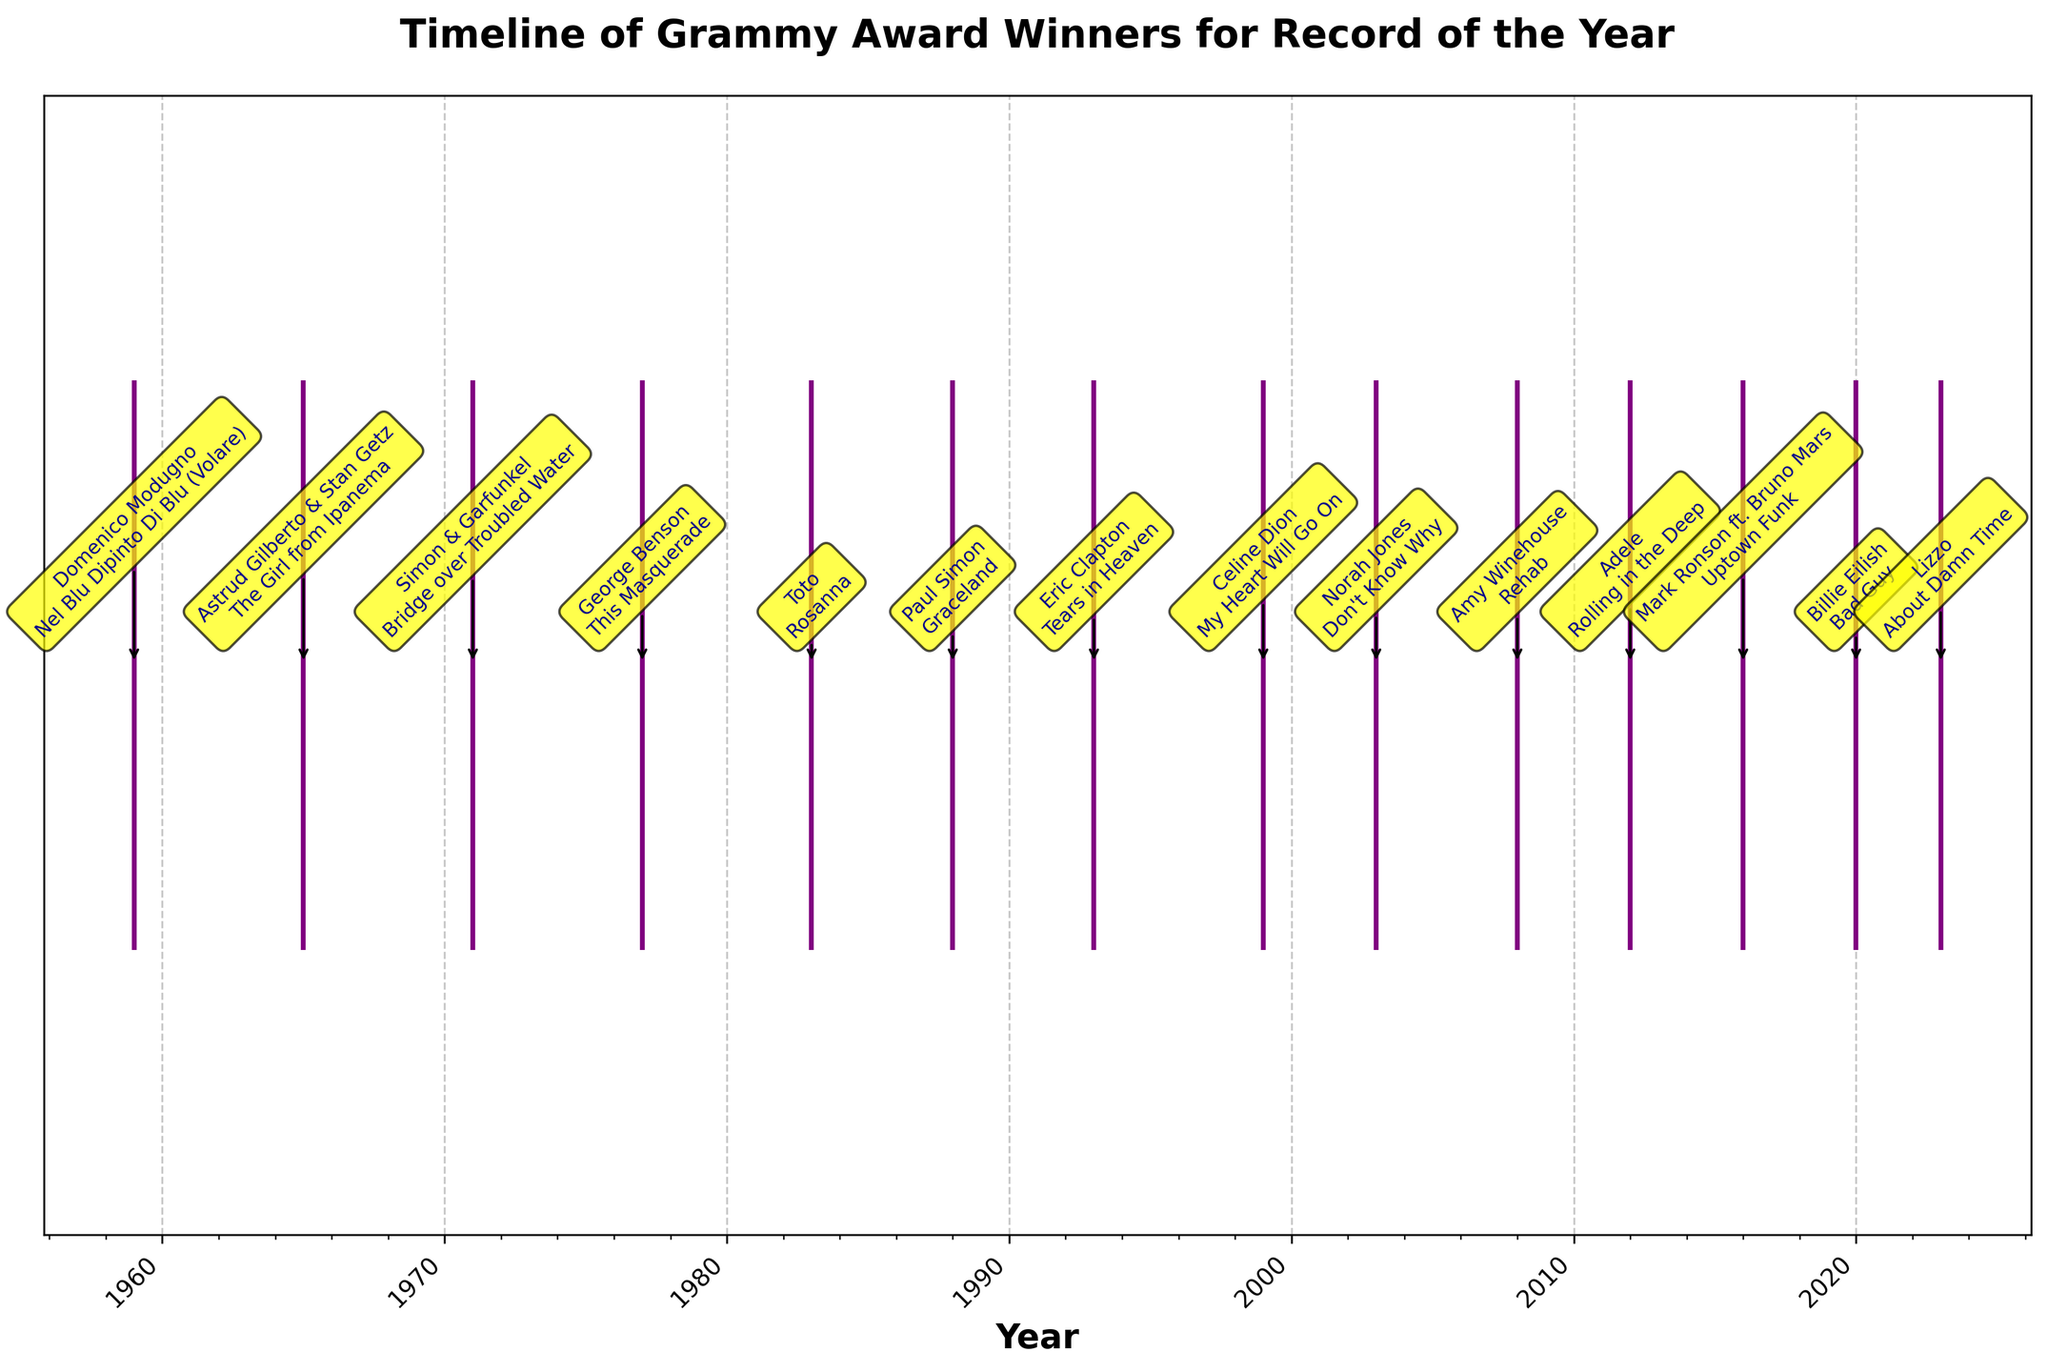What is the title of the figure? The title represents the main theme or subject of the plot. It helps you to understand the context of the data presented. In this case, the title is written at the top of the plot.
Answer: Timeline of Grammy Award Winners for Record of the Year What color are the lines representing the years in the eventplot? The lines representing the years are all depicted in a consistent color. By examining the lines, you can see they are colored purple.
Answer: Purple How many major ticks are placed on the x-axis? Major ticks are used to mark significant points or intervals on the axis, making it easier to read. By counting the major ticks, represented by the formatted years, you can determine this number.
Answer: 7 Which artist and song won the Grammy Award for Record of the Year in 2008? By locating the year 2008 on the x-axis and reading the annotation connected to that point, we find the artist and song for the specified year.
Answer: Amy Winehouse, Rehab Who is the most recent Grammy Award winner for Record of the Year according to the timeline? The most recent winner can be identified by looking at the point furthest to the right on the x-axis. The annotation connected to this point provides the artist and song.
Answer: Lizzo, About Damn Time Between 2012 and 2020, how many different artists won the Grammy Award for Record of the Year? Locate the years 2012 and 2020 on the x-axis, and count the number of unique artists listed in the annotations between these two points, inclusive.
Answer: 4 Was there a greater time gap between the 1959 and 1965 winners or the 1988 and 1993 winners? Calculate the number of years between 1959 and 1965 (1965-1959=6) and between 1988 and 1993 (1993-1988=5), then compare the two values.
Answer: 1959 and 1965 Which year had the winning artist Paul Simon and which song did he win with? Find the annotation labeled with Paul Simon by inspecting the annotations. Then, match this to the appropriate year and song.
Answer: 1988, Graceland How frequently do major ticks occur on the x-axis? Major ticks often follow a regular interval. By identifying the years marked by major ticks and determining their differences, the frequency can be deduced.
Answer: Every 10 years 